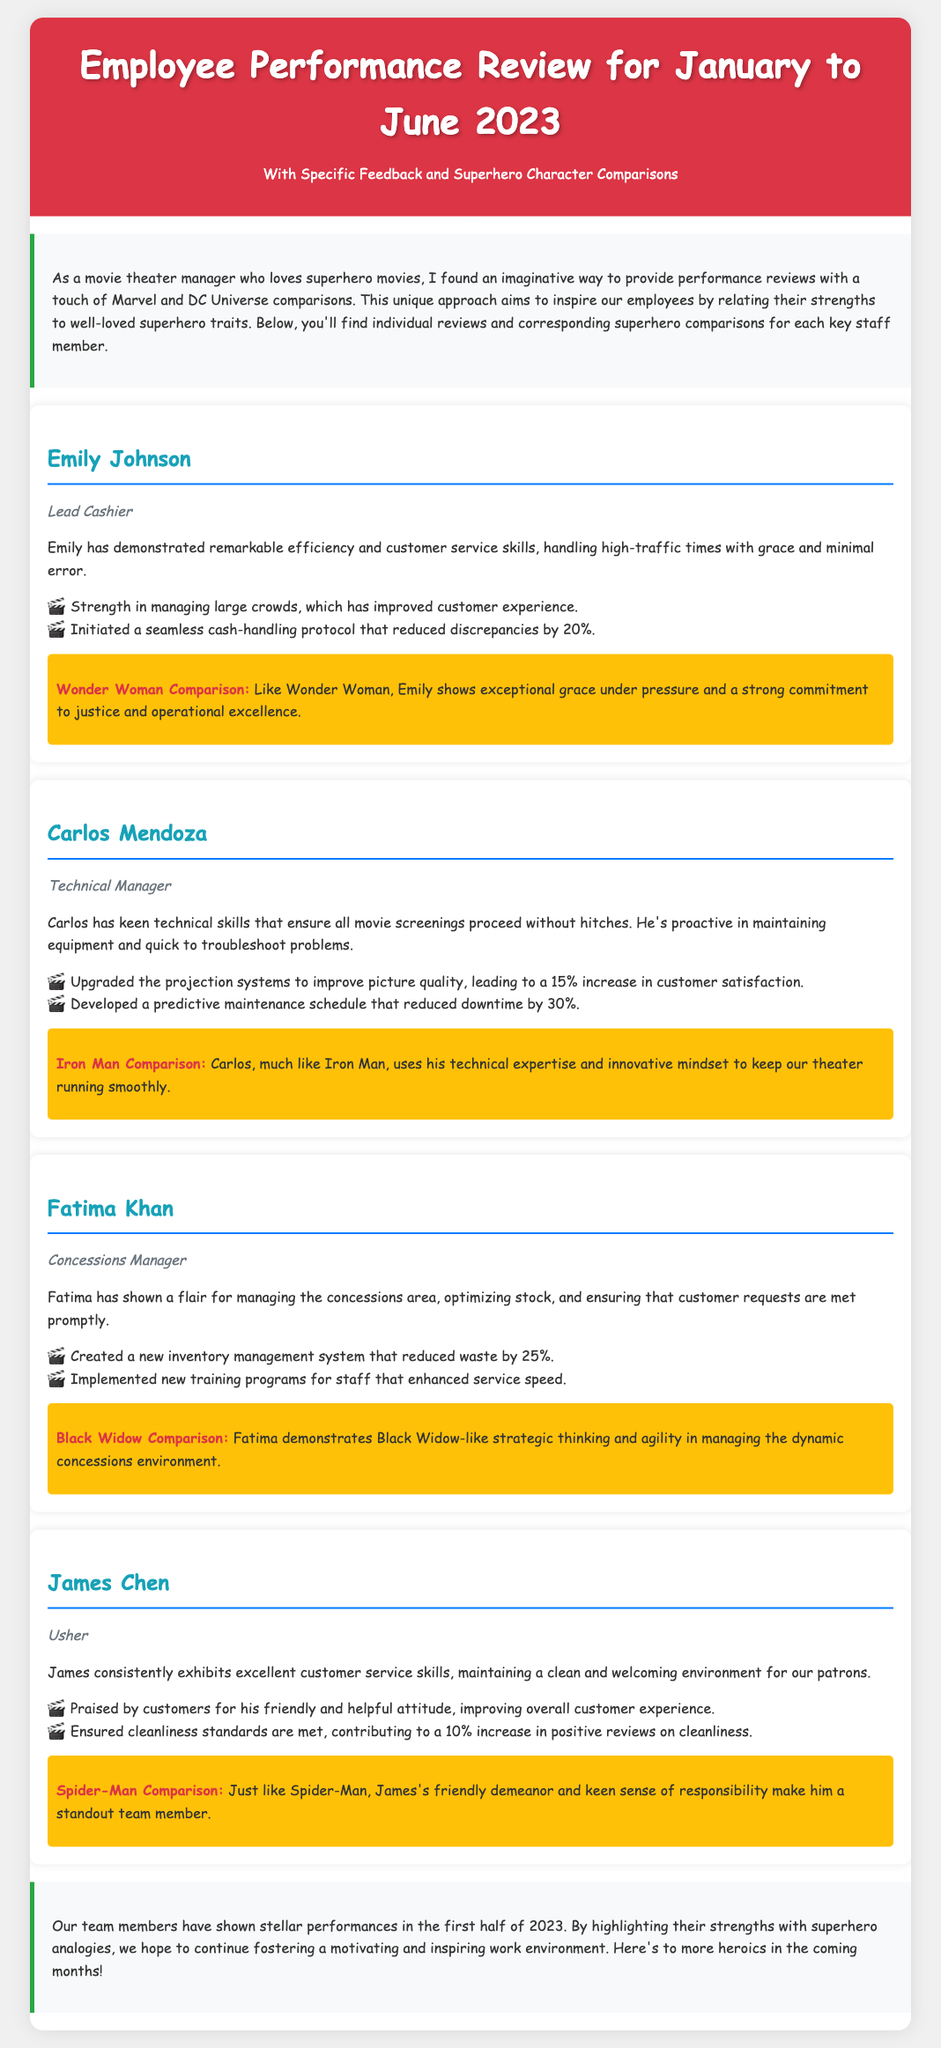What is the time period of the performance review? The document specifies the performance review is for January to June 2023.
Answer: January to June 2023 Who is the Lead Cashier? The document lists Emily Johnson as the Lead Cashier.
Answer: Emily Johnson What percentage did the cash-handling protocol reduce discrepancies by? The feedback states it reduced discrepancies by 20%.
Answer: 20% Which superhero is Carlos Mendoza compared to? The document compares Carlos Mendoza to Iron Man.
Answer: Iron Man What percentage increase in customer satisfaction resulted from the upgrade of the projection systems? The feedback indicates a 15% increase in customer satisfaction.
Answer: 15% What improvement did Fatima Khan's inventory management system achieve? It reduced waste by 25%.
Answer: 25% Who received praise for maintaining cleanliness standards? The document states that James Chen received praise for cleanliness standards.
Answer: James Chen What trait does Emily Johnson exhibit like Wonder Woman? The document notes that Emily shows exceptional grace under pressure.
Answer: Grace under pressure What innovative aspect does Carlos Mendoza bring to the technical management role? The feedback highlights that he developed a predictive maintenance schedule.
Answer: Predictive maintenance schedule 